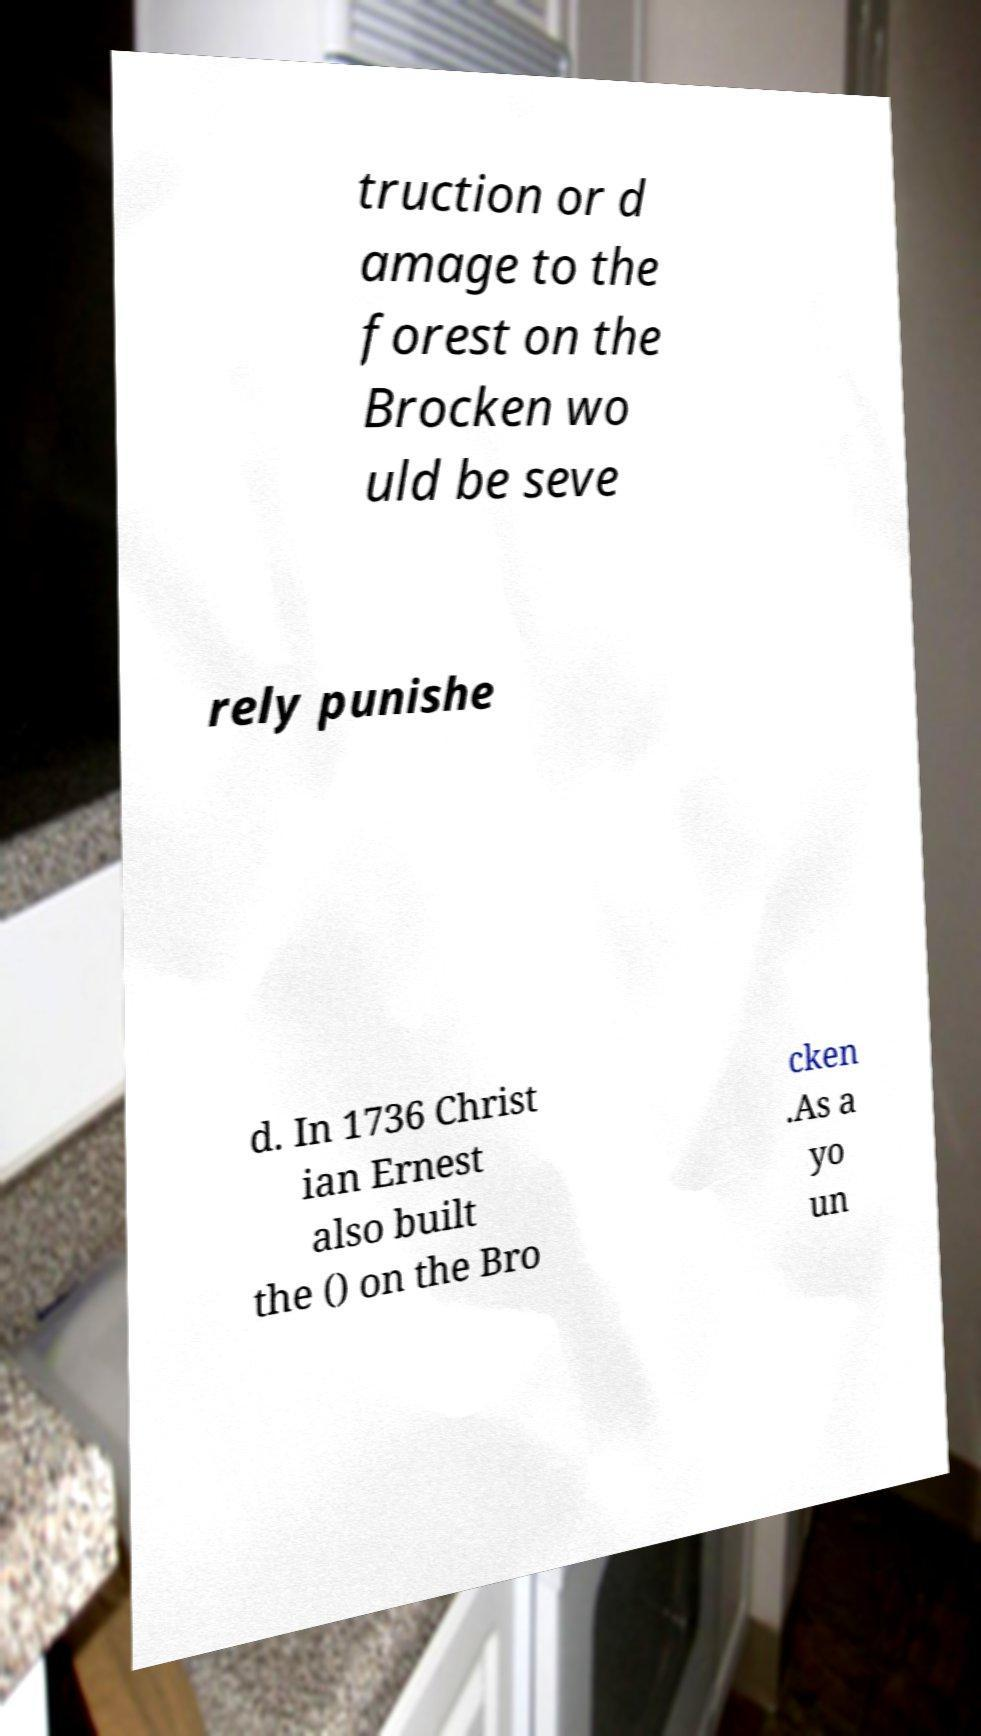Can you read and provide the text displayed in the image?This photo seems to have some interesting text. Can you extract and type it out for me? truction or d amage to the forest on the Brocken wo uld be seve rely punishe d. In 1736 Christ ian Ernest also built the () on the Bro cken .As a yo un 